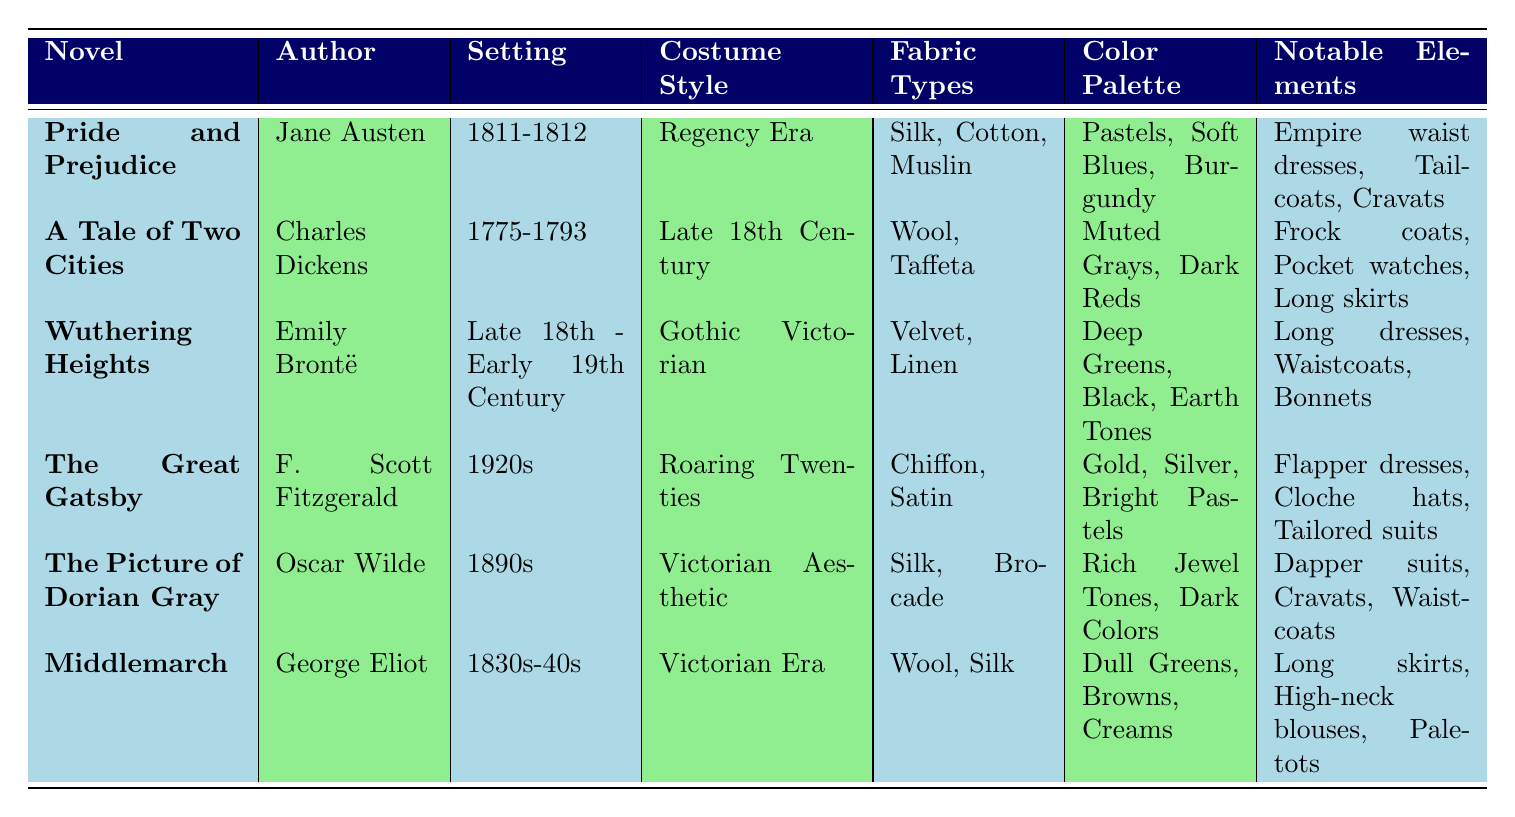What is the costume style for "Pride and Prejudice"? The table clearly indicates that the costume style for "Pride and Prejudice" is "Regency Era."
Answer: Regency Era Which novel is set in the 1920s? Referring to the "Setting" column, the table shows that "The Great Gatsby" is set in the 1920s.
Answer: The Great Gatsby How many main characters are listed for "A Tale of Two Cities"? Looking at the "main_characters" column, "A Tale of Two Cities" has three main characters: Charles Darnay, Sydney Carton, and Lucie Manette.
Answer: Three What are the notable costume elements of "Wuthering Heights"? The "Notable Elements" column describes that the notable costume elements for "Wuthering Heights" include Long dresses, Waistcoats, and Bonnets.
Answer: Long dresses, Waistcoats, Bonnets What is the color palette used in "The Picture of Dorian Gray"? In the "Color Palette" column for "The Picture of Dorian Gray," it lists Rich Jewel Tones and Dark Colors.
Answer: Rich Jewel Tones, Dark Colors Which author wrote the novel set in the 1830s-40s? The table indicates that George Eliot authored the novel "Middlemarch," which is set in the 1830s-40s.
Answer: George Eliot Do any of the novels feature cravats as a notable costume element? By checking the "Notable Elements" column, cravats are mentioned as elements for "Pride and Prejudice" and "The Picture of Dorian Gray." Therefore, the answer is yes.
Answer: Yes What is the difference in the setting years between "Wuthering Heights" and "A Tale of Two Cities"? "Wuthering Heights" is set from the Late 18th Century to the Early 19th Century, and "A Tale of Two Cities" is set from 1775 to 1793. The difference can be considered from 1775 to 1830 as an approximate range or as defined separately, resulting in a range of about 50 to 75 years.
Answer: Approximately 50 to 75 years Which novel used silk and brocade as fabric types? Looking into the "Fabric Types" column, the table shows that "The Picture of Dorian Gray" is the only novel that mentions both silk and brocade as fabric types.
Answer: The Picture of Dorian Gray Which costume style uses flapper dresses as notable elements? The table lists "Flapper dresses" under the "Notable Elements" for "The Great Gatsby," indicating it utilizes that costume style.
Answer: The Great Gatsby 